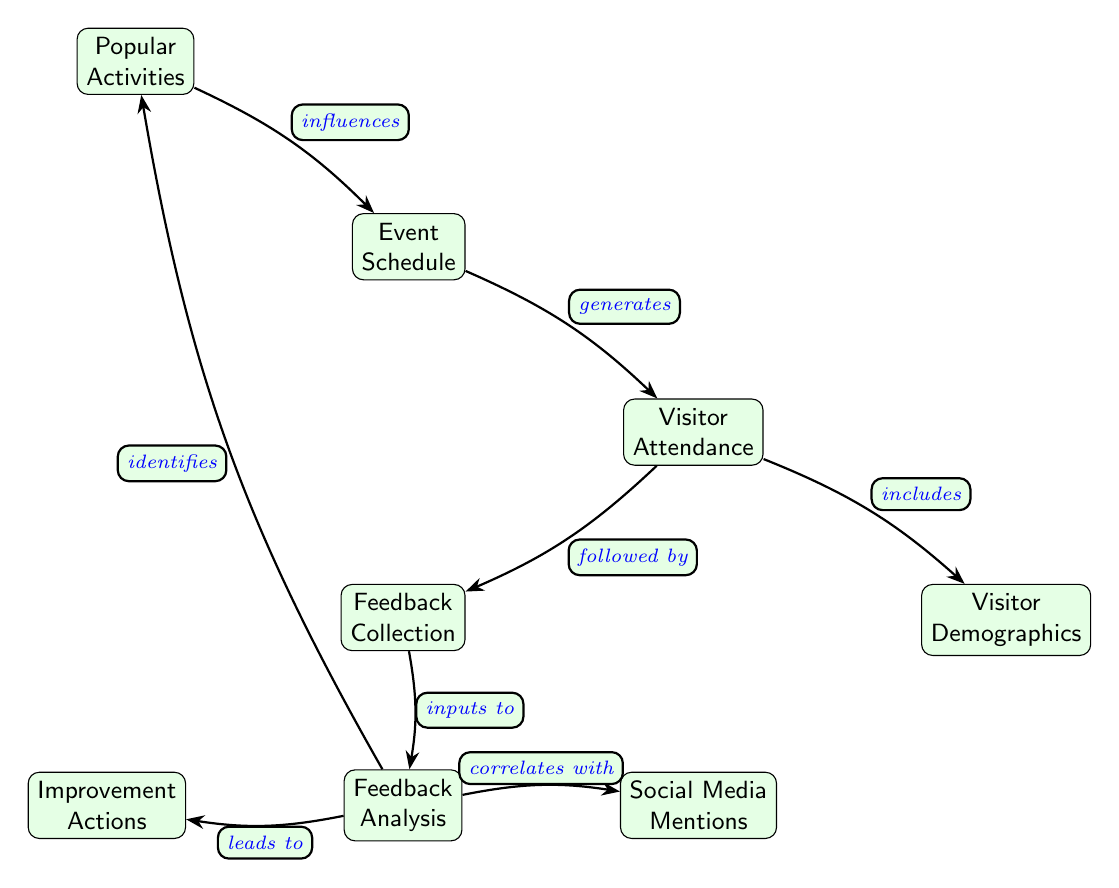What generates Visitor Attendance? The event schedule generates visitor attendance by planning specified events that attract visitors to the garden.
Answer: Event Schedule How many nodes are in the diagram? The diagram contains seven nodes representing different components of visitor attendance trends and feedback analysis.
Answer: Seven What does Feedback Analysis lead to? Feedback analysis leads to improvement actions as it evaluates the collected feedback to identify areas of enhancement for future events.
Answer: Improvement Actions Which node influences Event Schedule? Popular activities influence the event schedule by informing the organization about what activities are most appealing to attendees, helping to attract more visitors.
Answer: Popular Activities How does Feedback Collection relate to Visitor Attendance? Feedback collection is followed by visitor attendance, establishing that after visitors attend the event, their feedback is collected to assess their experience.
Answer: Followed by What correlates with Social Media Mentions? Feedback analysis correlates with social media mentions, indicating that public sentiment expressed through social platforms can reflect the feedback received from visitors.
Answer: Feedback Analysis What identifies Popular Activities? Feedback analysis identifies popular activities by analyzing visitor responses, pinpointing which activities were most enjoyed or appreciated.
Answer: Feedback Analysis Which two nodes are directly connected to Visitor Attendance? Visitor attendance is directly connected to demographics and feedback collection, showing that both aspects are essential in understanding visitor profiles and gathering their feedback.
Answer: Demographics, Feedback Collection 